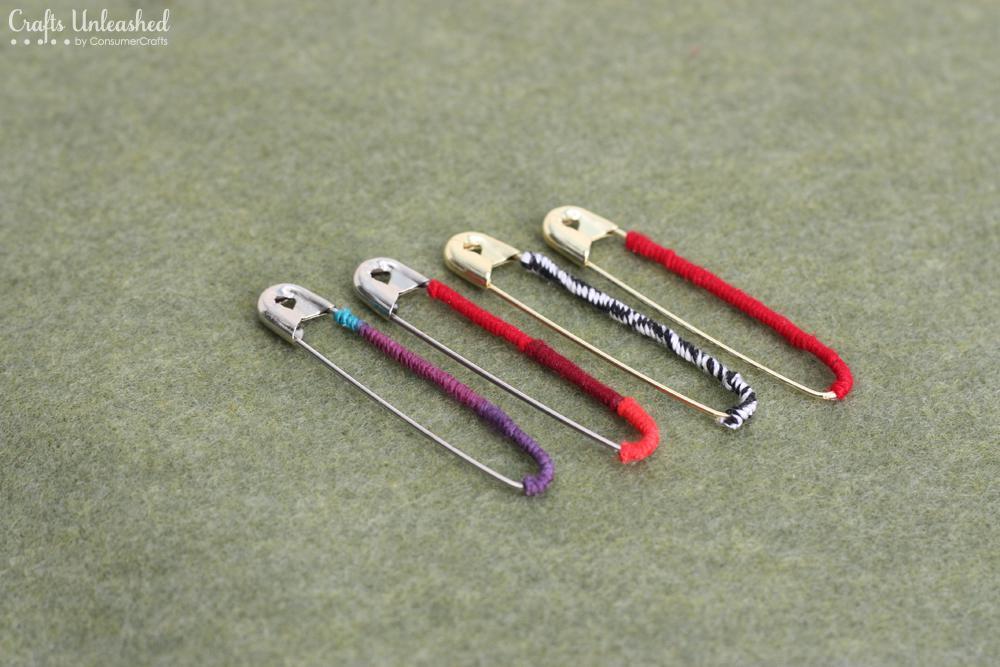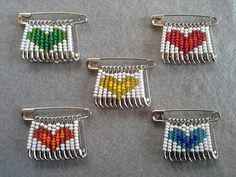The first image is the image on the left, the second image is the image on the right. For the images shown, is this caption "At least one of the images displays a pin with a heart pennant." true? Answer yes or no. Yes. The first image is the image on the left, the second image is the image on the right. Assess this claim about the two images: "An image includes a pin jewelry creation with beads that form a heart shape.". Correct or not? Answer yes or no. Yes. 